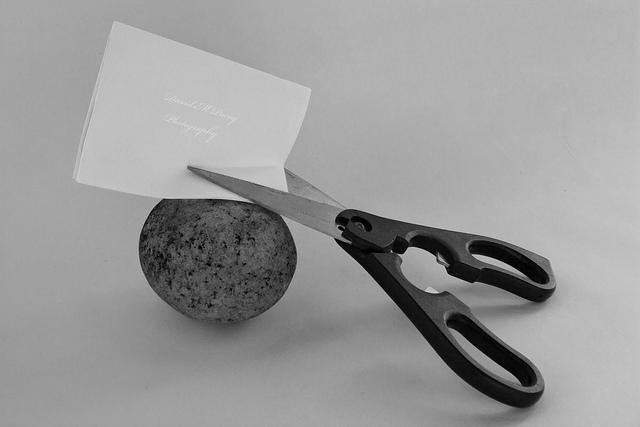How many objects are in this photo?
Give a very brief answer. 3. 